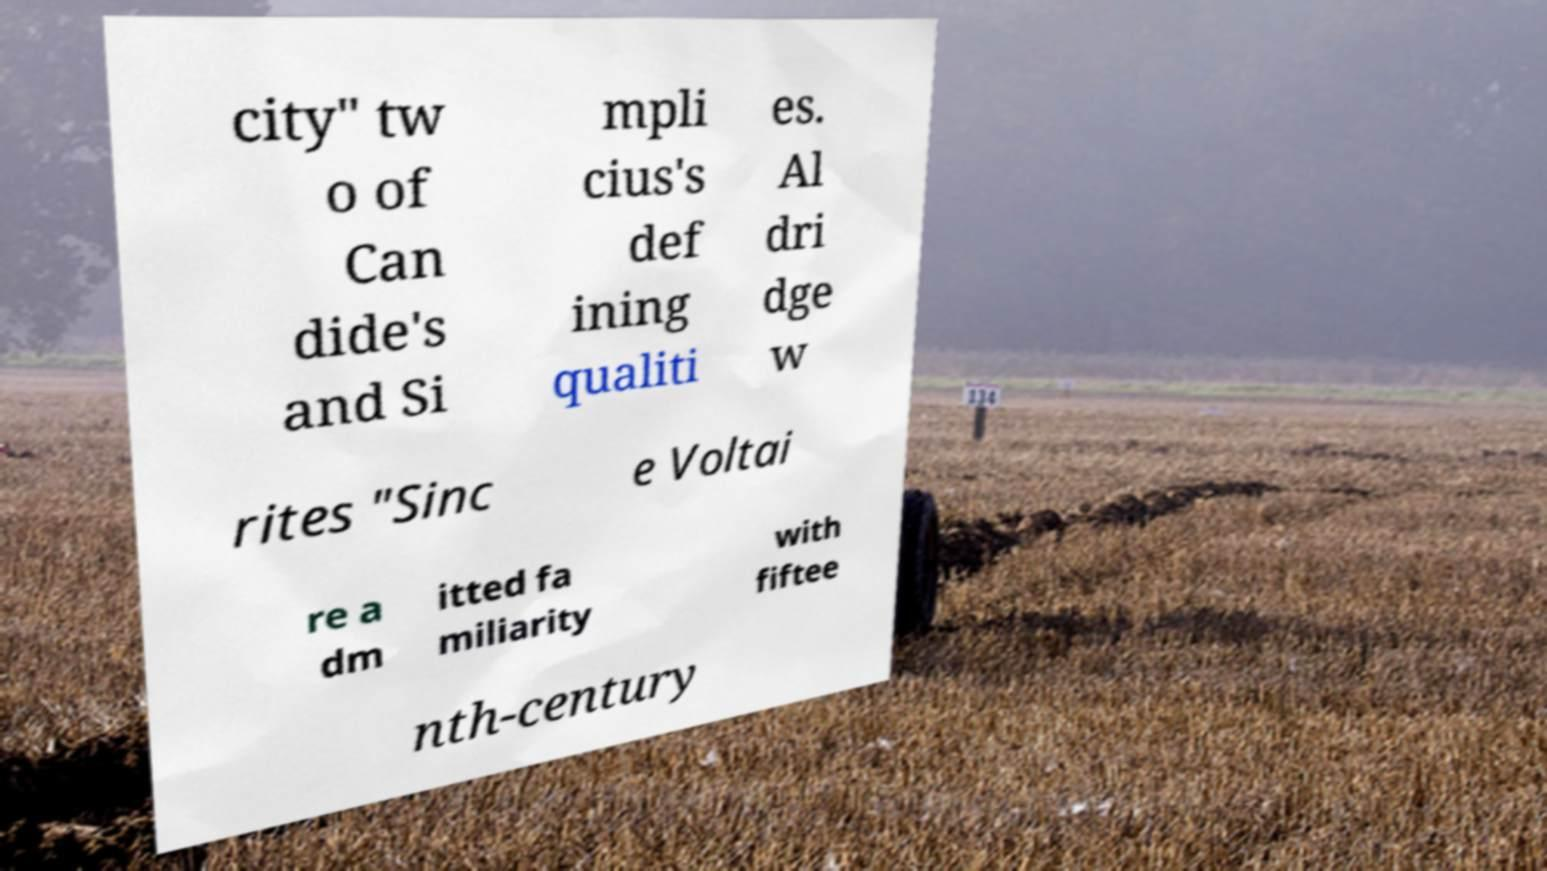Could you extract and type out the text from this image? city" tw o of Can dide's and Si mpli cius's def ining qualiti es. Al dri dge w rites "Sinc e Voltai re a dm itted fa miliarity with fiftee nth-century 